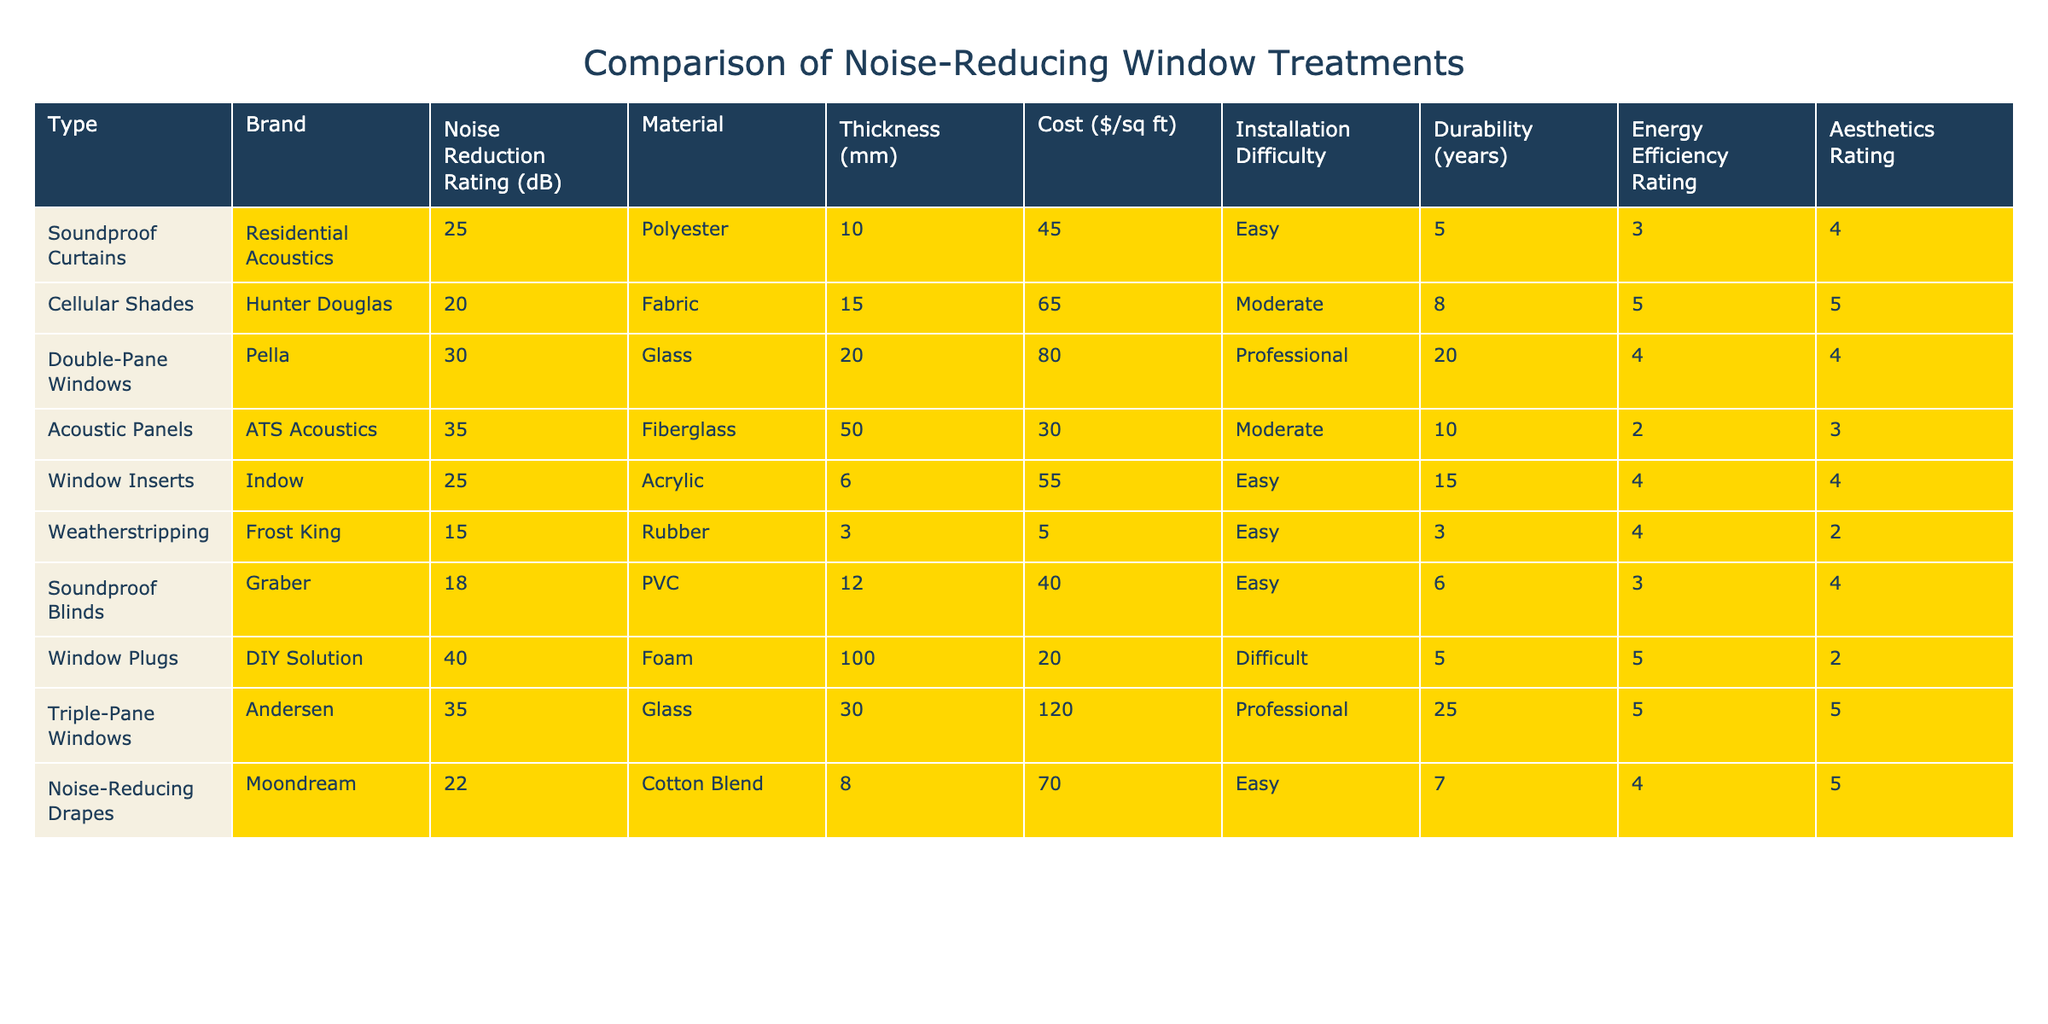What is the highest Noise Reduction Rating among the window treatments? Looking at the "Noise Reduction Rating (dB)" column, the highest value is 40, which corresponds to "Window Plugs."
Answer: 40 Which treatment has the lowest durability rating? By examining the "Durability (years)" column, the minimum value is 3, which belongs to "Weatherstripping."
Answer: Weatherstripping What is the average cost of the listed treatments? The costs are 45, 65, 80, 30, 55, 5, 40, 20, 120, and 70. Adding these values results in 510. There are 10 treatments, so the average cost is 510/10 = 51.
Answer: 51 Is there a treatment that is both easy to install and has a Noise Reduction Rating above 20? The "Noise Reduction Rating (dB)" for easy-to-install treatments are 25 (Soundproof Curtains) and 25 (Window Inserts), both of which exceed 20. Thus, the answer is yes.
Answer: Yes What is the difference in Noise Reduction Rating between the best and worst treatments? The best rating is 40 ("Window Plugs") and the worst is 15 ("Weatherstripping"). The difference is 40 - 15 = 25.
Answer: 25 How many treatments have an Energy Efficiency Rating of 5? The treatments with an Energy Efficiency Rating of 5 are "Cellular Shades," "Triple-Pane Windows," and "Noise-Reducing Drapes," totaling 3 treatments.
Answer: 3 Which material is the most common among the listed treatments? Reviewing the "Material" column, several treatments use different materials, but "Glass" appears twice, corresponding to "Double-Pane Windows" and "Triple-Pane Windows," which is the most common.
Answer: Glass Does any treatment have a Cost per square foot of less than $20? The "Cost ($/sq ft)" values indicate that the lowest cost is 5 ("Weatherstripping"), which is indeed less than $20. Thus, the answer is yes.
Answer: Yes Which window treatment offers the highest Energy Efficiency Rating? The highest value in the "Energy Efficiency Rating" column is 5, found in "Cellular Shades," "Triple-Pane Windows," and "Noise-Reducing Drapes."
Answer: Cellular Shades, Triple-Pane Windows, Noise-Reducing Drapes 